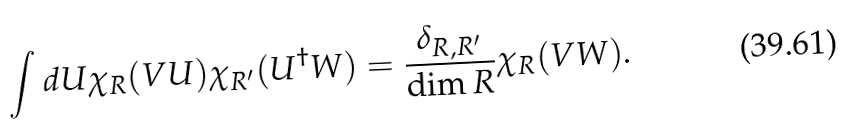Convert formula to latex. <formula><loc_0><loc_0><loc_500><loc_500>\int d U \chi _ { R } ( V U ) \chi _ { R ^ { \prime } } ( U ^ { \dagger } W ) = \frac { \delta _ { R , R ^ { \prime } } } { \dim R } \chi _ { R } ( V W ) .</formula> 